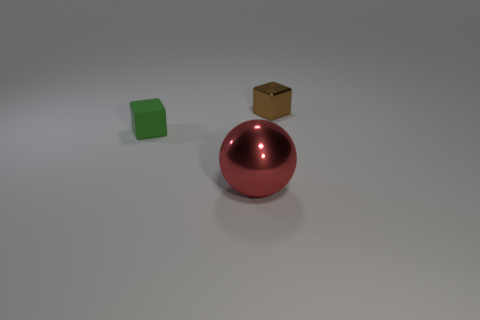There is a small object in front of the brown cube; is it the same shape as the tiny thing that is on the right side of the large metal sphere?
Offer a terse response. Yes. Is there any other thing that is the same shape as the big red object?
Ensure brevity in your answer.  No. The red thing that is made of the same material as the brown block is what shape?
Your answer should be very brief. Sphere. Are there the same number of red metallic balls that are to the left of the tiny rubber object and metallic cubes?
Your response must be concise. No. Is the thing on the right side of the large red ball made of the same material as the red sphere that is to the right of the rubber thing?
Your response must be concise. Yes. What is the shape of the object that is in front of the green rubber object in front of the small brown thing?
Your response must be concise. Sphere. What is the color of the cube that is the same material as the big ball?
Offer a terse response. Brown. Is the tiny matte thing the same color as the shiny cube?
Give a very brief answer. No. There is a green thing that is the same size as the brown metal thing; what is its shape?
Give a very brief answer. Cube. What size is the green block?
Make the answer very short. Small. 